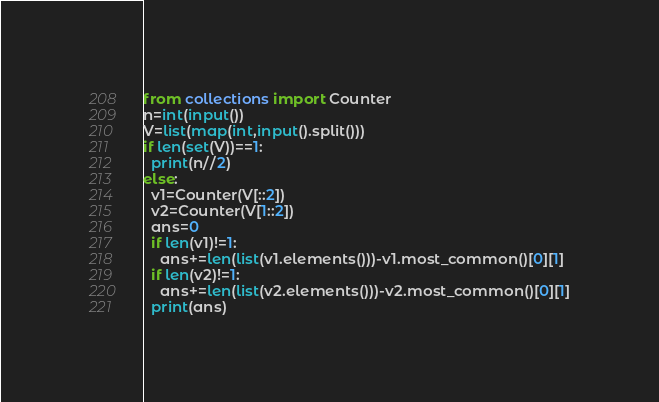<code> <loc_0><loc_0><loc_500><loc_500><_Python_>from collections import Counter
n=int(input())
V=list(map(int,input().split()))
if len(set(V))==1:
  print(n//2)
else:
  v1=Counter(V[::2])
  v2=Counter(V[1::2])
  ans=0
  if len(v1)!=1:
    ans+=len(list(v1.elements()))-v1.most_common()[0][1]
  if len(v2)!=1:
    ans+=len(list(v2.elements()))-v2.most_common()[0][1]
  print(ans)</code> 